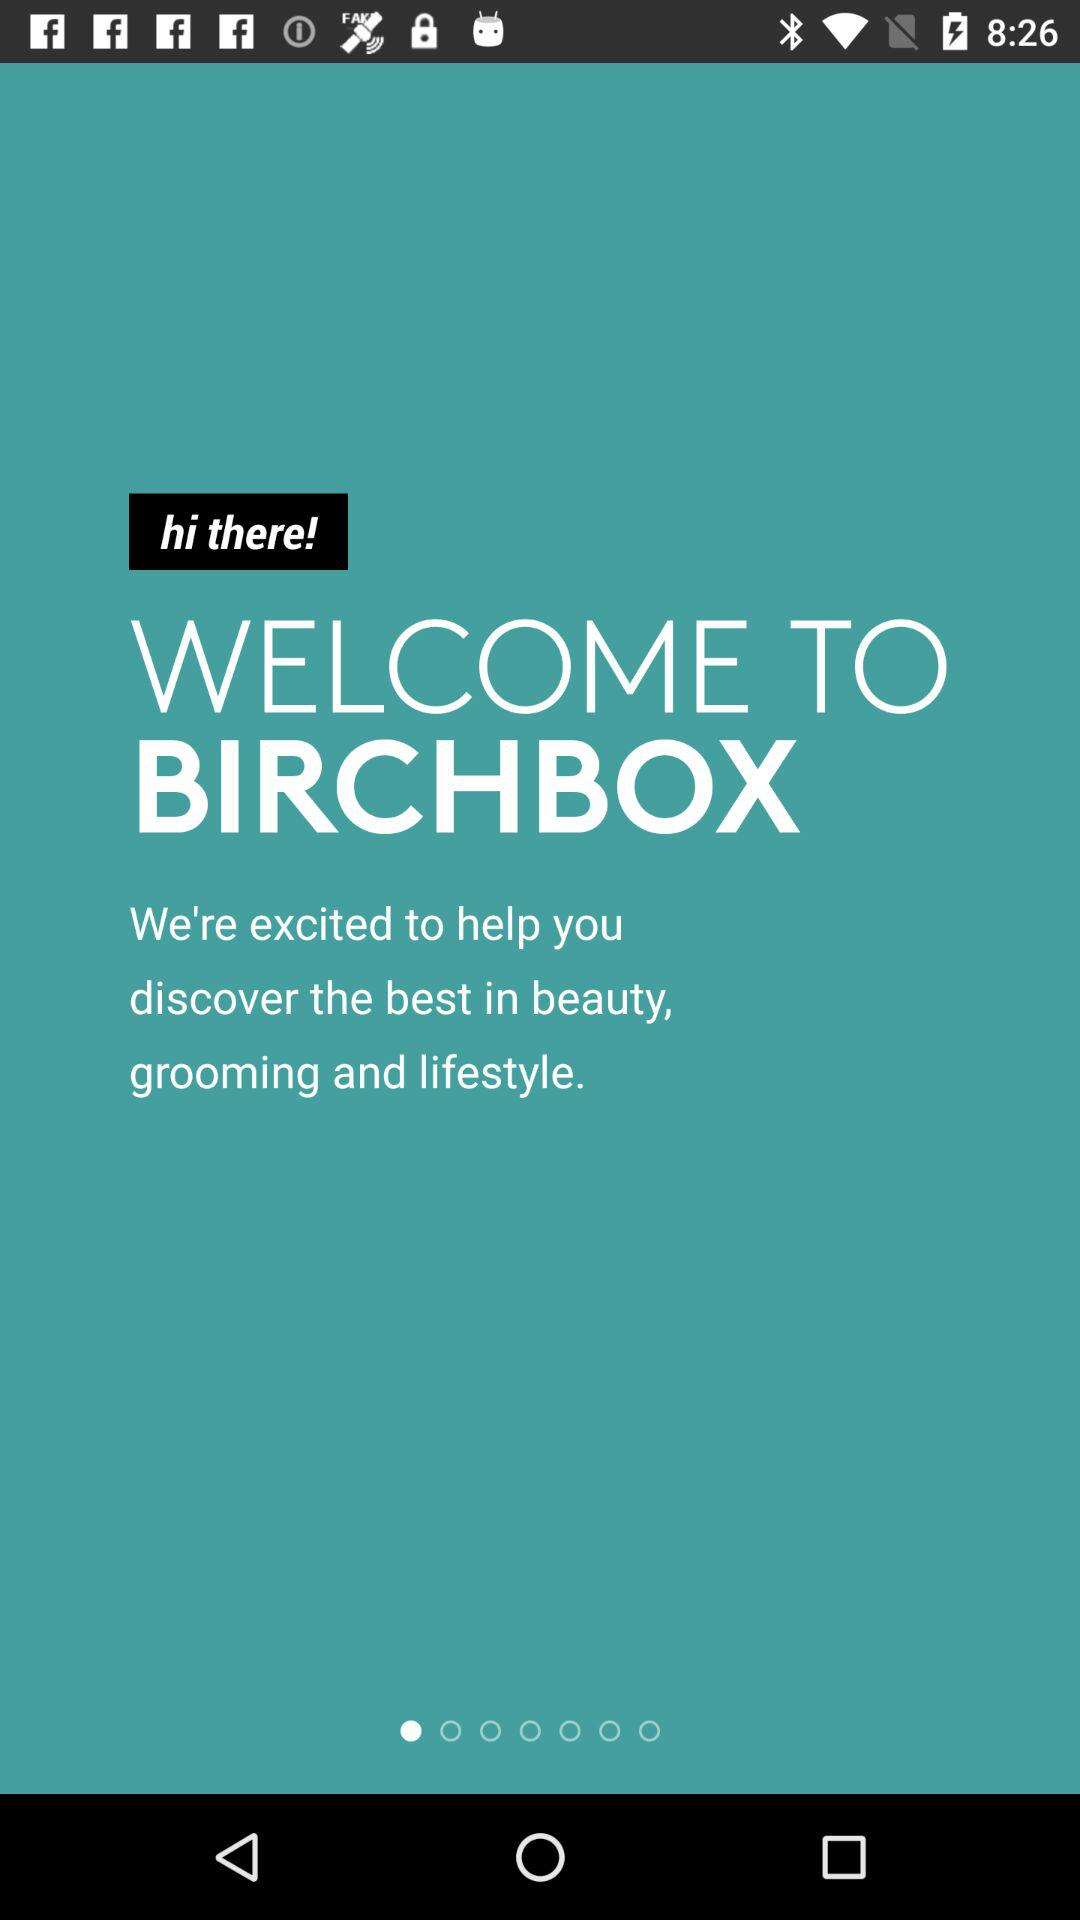What is the app name? The app name is "BIRCHBOX". 